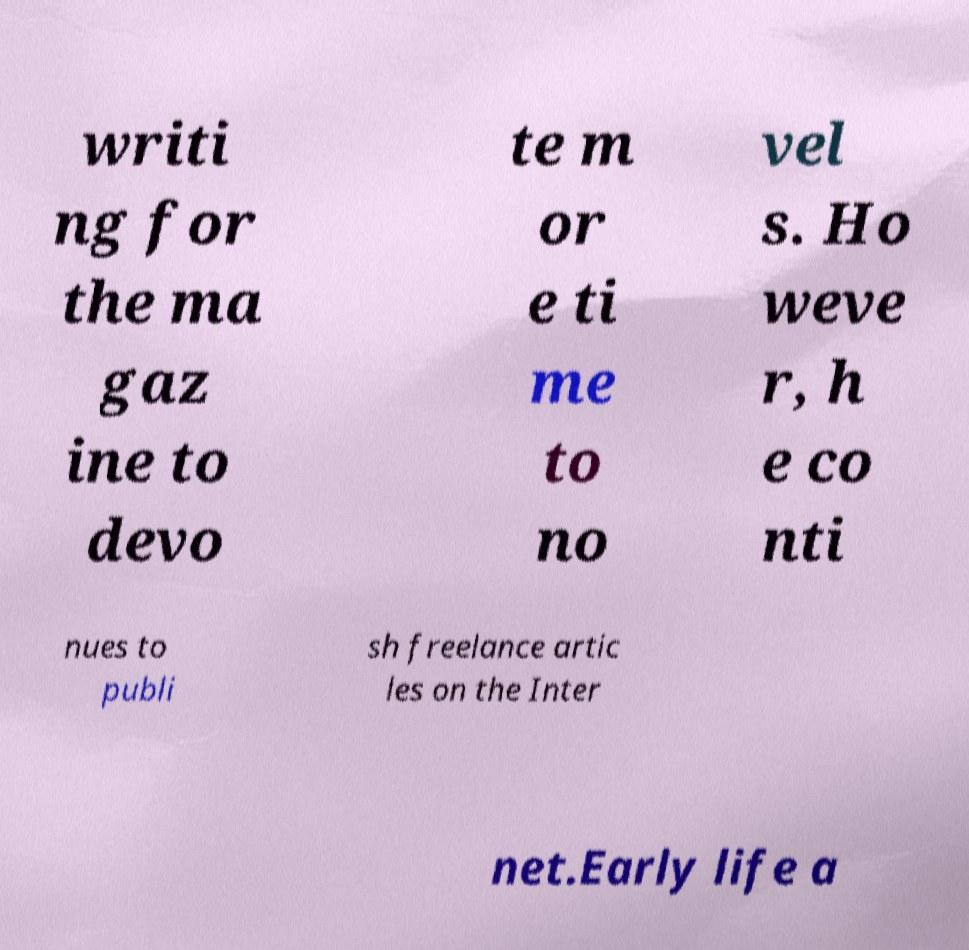Can you accurately transcribe the text from the provided image for me? writi ng for the ma gaz ine to devo te m or e ti me to no vel s. Ho weve r, h e co nti nues to publi sh freelance artic les on the Inter net.Early life a 